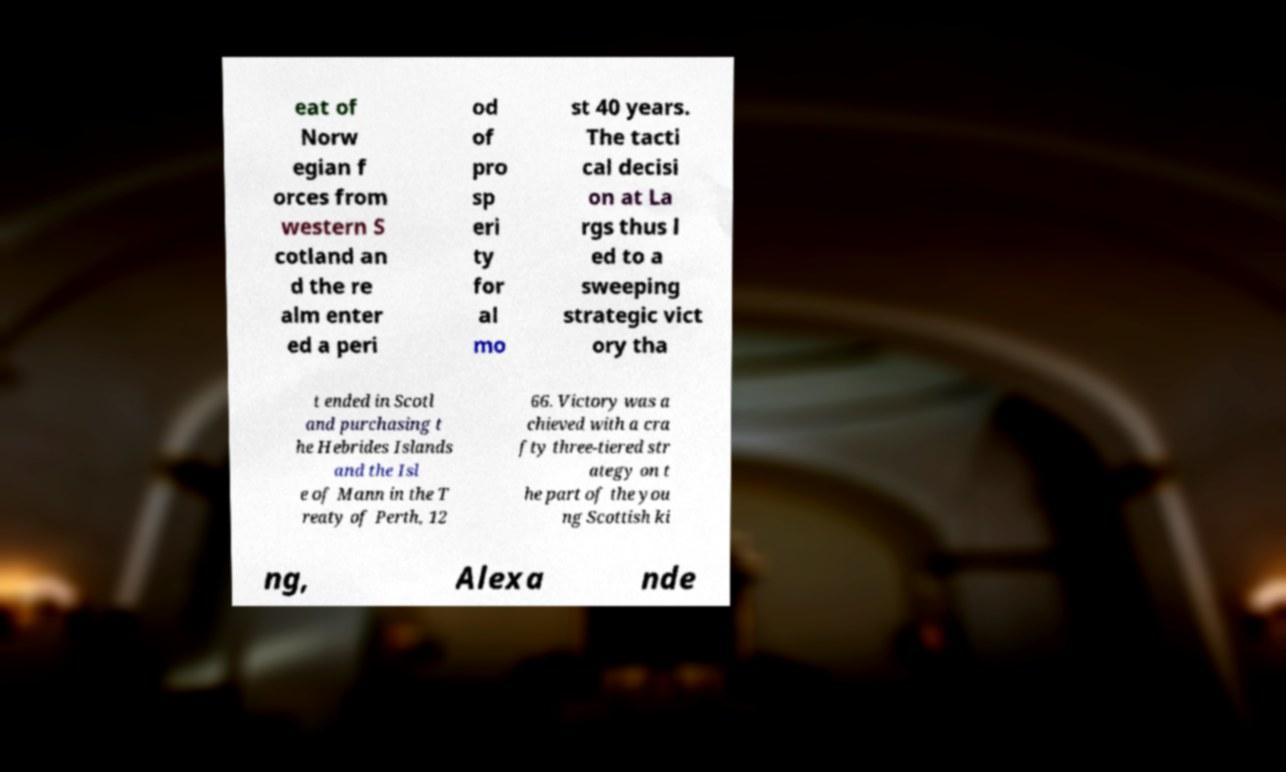Please read and relay the text visible in this image. What does it say? eat of Norw egian f orces from western S cotland an d the re alm enter ed a peri od of pro sp eri ty for al mo st 40 years. The tacti cal decisi on at La rgs thus l ed to a sweeping strategic vict ory tha t ended in Scotl and purchasing t he Hebrides Islands and the Isl e of Mann in the T reaty of Perth, 12 66. Victory was a chieved with a cra fty three-tiered str ategy on t he part of the you ng Scottish ki ng, Alexa nde 